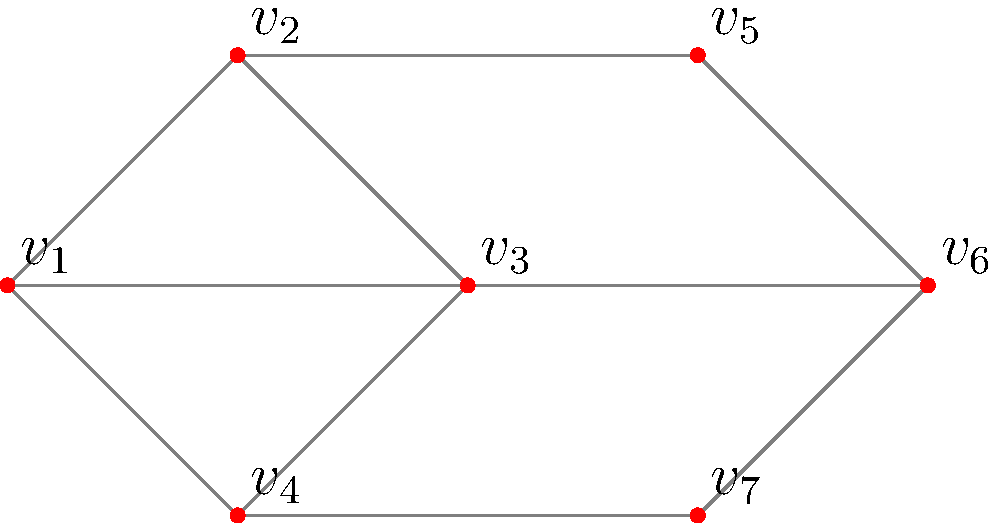In the context of social network analysis, consider the graph above representing connections between individuals. Drawing inspiration from Euler's work on the Seven Bridges of Königsberg problem, determine if it's possible to traverse this network by visiting each connection exactly once, starting and ending at the same vertex. If possible, provide the sequence of vertices for such a traversal. If not, explain why using graph theory concepts. To solve this problem, we'll use concepts from Euler's work and apply them to modern social network analysis:

1. First, recall Euler's theorem: A connected graph has an Euler circuit if and only if every vertex has an even degree.

2. Let's count the degree of each vertex:
   $v_1$: degree 3
   $v_2$: degree 3
   $v_3$: degree 4
   $v_4$: degree 3
   $v_5$: degree 2
   $v_6$: degree 3
   $v_7$: degree 2

3. We observe that vertices $v_1$, $v_2$, $v_4$, and $v_6$ have odd degrees. According to Euler's theorem, this graph does not have an Euler circuit.

4. In social network terms, this means we cannot start at any individual, traverse each connection exactly once, and return to the starting point.

5. However, we can find an Euler path if there are exactly two vertices with odd degree. In this case, we have four vertices with odd degree, so an Euler path is also impossible.

6. This result illustrates an important concept in social network analysis: not all networks have a "perfect" traversal path. In real-world social networks, this could indicate the need for multiple entry points or the existence of subgroups within the network.

7. To make this network Eulerian, we would need to add two edges connecting the odd-degree vertices. For example, adding edges $(v_1, v_4)$ and $(v_2, v_6)$ would make all vertices have even degree, allowing for an Euler circuit.
Answer: No Euler circuit exists; 4 odd-degree vertices. 